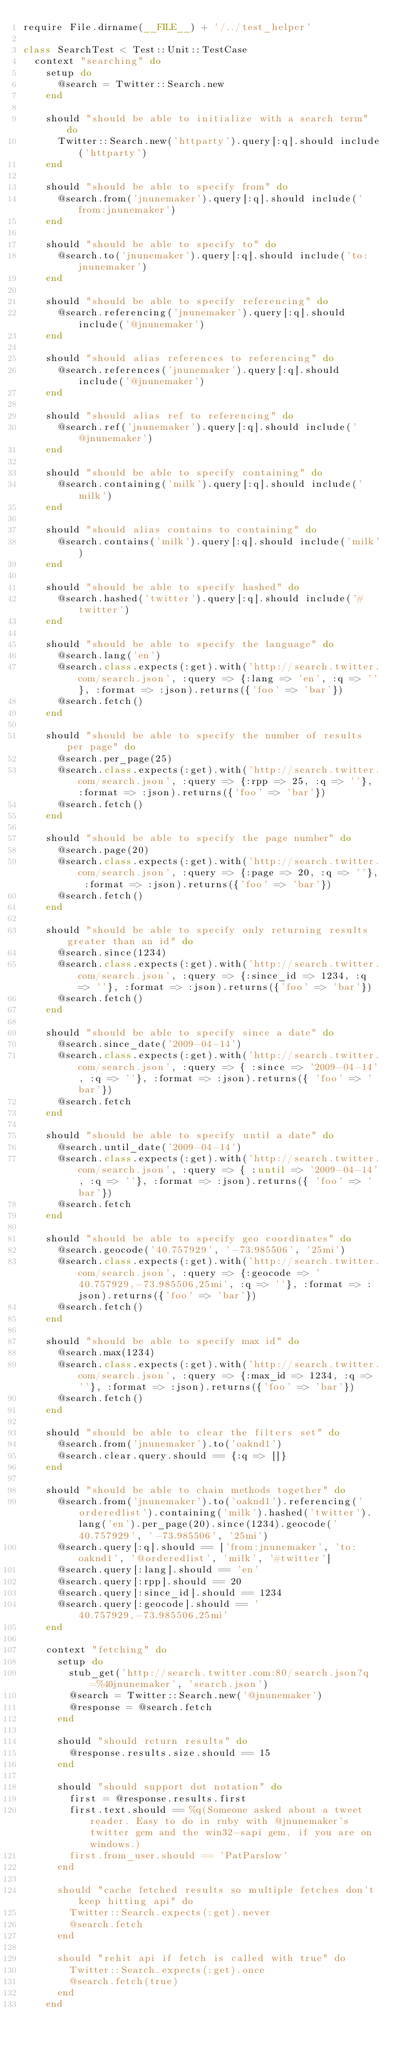<code> <loc_0><loc_0><loc_500><loc_500><_Ruby_>require File.dirname(__FILE__) + '/../test_helper'

class SearchTest < Test::Unit::TestCase
  context "searching" do
    setup do
      @search = Twitter::Search.new
    end

    should "should be able to initialize with a search term" do
      Twitter::Search.new('httparty').query[:q].should include('httparty')
    end

    should "should be able to specify from" do
      @search.from('jnunemaker').query[:q].should include('from:jnunemaker')
    end

    should "should be able to specify to" do
      @search.to('jnunemaker').query[:q].should include('to:jnunemaker')
    end

    should "should be able to specify referencing" do
      @search.referencing('jnunemaker').query[:q].should include('@jnunemaker')
    end

    should "should alias references to referencing" do
      @search.references('jnunemaker').query[:q].should include('@jnunemaker')
    end

    should "should alias ref to referencing" do
      @search.ref('jnunemaker').query[:q].should include('@jnunemaker')
    end

    should "should be able to specify containing" do
      @search.containing('milk').query[:q].should include('milk')
    end

    should "should alias contains to containing" do
      @search.contains('milk').query[:q].should include('milk')
    end  

    should "should be able to specify hashed" do
      @search.hashed('twitter').query[:q].should include('#twitter')
    end

    should "should be able to specify the language" do
      @search.lang('en')
      @search.class.expects(:get).with('http://search.twitter.com/search.json', :query => {:lang => 'en', :q => ''}, :format => :json).returns({'foo' => 'bar'})
      @search.fetch()
    end

    should "should be able to specify the number of results per page" do
      @search.per_page(25)
      @search.class.expects(:get).with('http://search.twitter.com/search.json', :query => {:rpp => 25, :q => ''}, :format => :json).returns({'foo' => 'bar'})
      @search.fetch()
    end

    should "should be able to specify the page number" do
      @search.page(20)
      @search.class.expects(:get).with('http://search.twitter.com/search.json', :query => {:page => 20, :q => ''}, :format => :json).returns({'foo' => 'bar'})
      @search.fetch()
    end

    should "should be able to specify only returning results greater than an id" do
      @search.since(1234)
      @search.class.expects(:get).with('http://search.twitter.com/search.json', :query => {:since_id => 1234, :q => ''}, :format => :json).returns({'foo' => 'bar'})
      @search.fetch()
    end

    should "should be able to specify since a date" do 
      @search.since_date('2009-04-14')
      @search.class.expects(:get).with('http://search.twitter.com/search.json', :query => { :since => '2009-04-14', :q => ''}, :format => :json).returns({ 'foo' => 'bar'})
      @search.fetch
    end

    should "should be able to specify until a date" do 
      @search.until_date('2009-04-14')
      @search.class.expects(:get).with('http://search.twitter.com/search.json', :query => { :until => '2009-04-14', :q => ''}, :format => :json).returns({ 'foo' => 'bar'})
      @search.fetch
    end

    should "should be able to specify geo coordinates" do
      @search.geocode('40.757929', '-73.985506', '25mi')
      @search.class.expects(:get).with('http://search.twitter.com/search.json', :query => {:geocode => '40.757929,-73.985506,25mi', :q => ''}, :format => :json).returns({'foo' => 'bar'})
      @search.fetch()
    end

    should "should be able to specify max id" do
      @search.max(1234)
      @search.class.expects(:get).with('http://search.twitter.com/search.json', :query => {:max_id => 1234, :q => ''}, :format => :json).returns({'foo' => 'bar'})
      @search.fetch()
    end

    should "should be able to clear the filters set" do
      @search.from('jnunemaker').to('oaknd1')
      @search.clear.query.should == {:q => []}
    end

    should "should be able to chain methods together" do
      @search.from('jnunemaker').to('oaknd1').referencing('orderedlist').containing('milk').hashed('twitter').lang('en').per_page(20).since(1234).geocode('40.757929', '-73.985506', '25mi')
      @search.query[:q].should == ['from:jnunemaker', 'to:oaknd1', '@orderedlist', 'milk', '#twitter']
      @search.query[:lang].should == 'en'
      @search.query[:rpp].should == 20
      @search.query[:since_id].should == 1234
      @search.query[:geocode].should == '40.757929,-73.985506,25mi'
    end

    context "fetching" do
      setup do
        stub_get('http://search.twitter.com:80/search.json?q=%40jnunemaker', 'search.json')
        @search = Twitter::Search.new('@jnunemaker')
        @response = @search.fetch
      end

      should "should return results" do
        @response.results.size.should == 15
      end

      should "should support dot notation" do
        first = @response.results.first
        first.text.should == %q(Someone asked about a tweet reader. Easy to do in ruby with @jnunemaker's twitter gem and the win32-sapi gem, if you are on windows.)
        first.from_user.should == 'PatParslow'
      end
      
      should "cache fetched results so multiple fetches don't keep hitting api" do
        Twitter::Search.expects(:get).never
        @search.fetch
      end
      
      should "rehit api if fetch is called with true" do
        Twitter::Search.expects(:get).once
        @search.fetch(true)
      end
    end
    </code> 